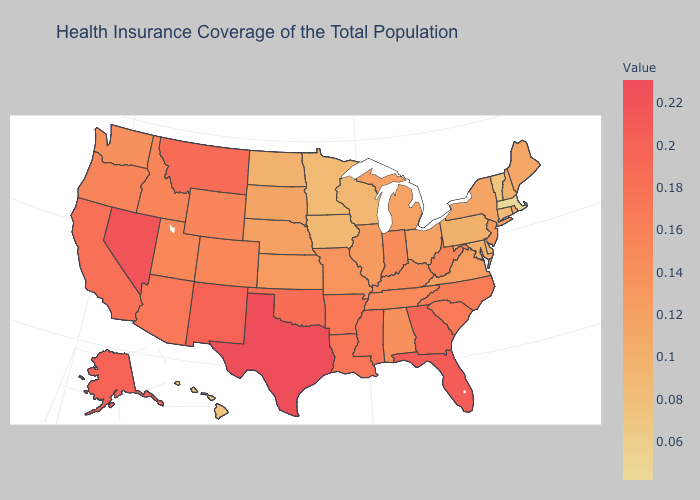Which states have the highest value in the USA?
Short answer required. Texas. Is the legend a continuous bar?
Short answer required. Yes. Which states have the lowest value in the USA?
Concise answer only. Massachusetts. 